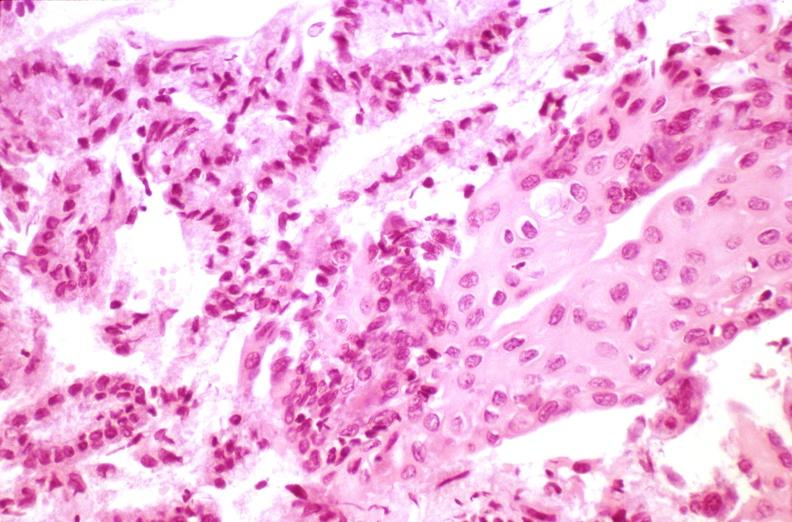what is present?
Answer the question using a single word or phrase. Female reproductive 